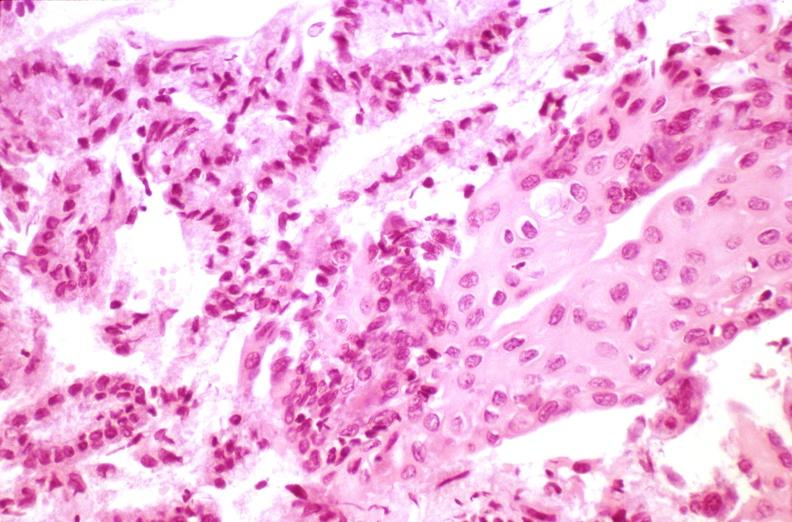what is present?
Answer the question using a single word or phrase. Female reproductive 